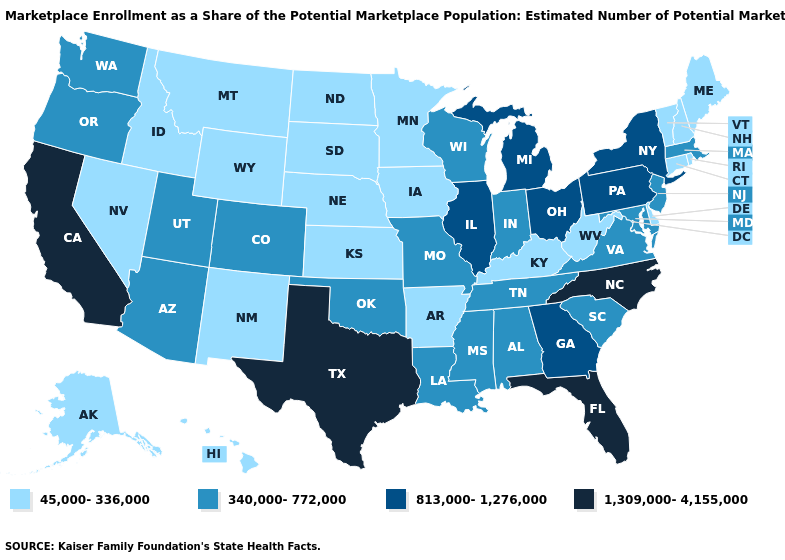How many symbols are there in the legend?
Concise answer only. 4. Name the states that have a value in the range 1,309,000-4,155,000?
Concise answer only. California, Florida, North Carolina, Texas. Which states hav the highest value in the West?
Write a very short answer. California. How many symbols are there in the legend?
Concise answer only. 4. What is the value of Iowa?
Write a very short answer. 45,000-336,000. Name the states that have a value in the range 1,309,000-4,155,000?
Concise answer only. California, Florida, North Carolina, Texas. Does Montana have a lower value than North Dakota?
Concise answer only. No. Does the first symbol in the legend represent the smallest category?
Give a very brief answer. Yes. What is the highest value in the USA?
Write a very short answer. 1,309,000-4,155,000. How many symbols are there in the legend?
Be succinct. 4. Name the states that have a value in the range 813,000-1,276,000?
Keep it brief. Georgia, Illinois, Michigan, New York, Ohio, Pennsylvania. Which states hav the highest value in the South?
Quick response, please. Florida, North Carolina, Texas. Among the states that border Montana , which have the highest value?
Be succinct. Idaho, North Dakota, South Dakota, Wyoming. Does the first symbol in the legend represent the smallest category?
Quick response, please. Yes. 